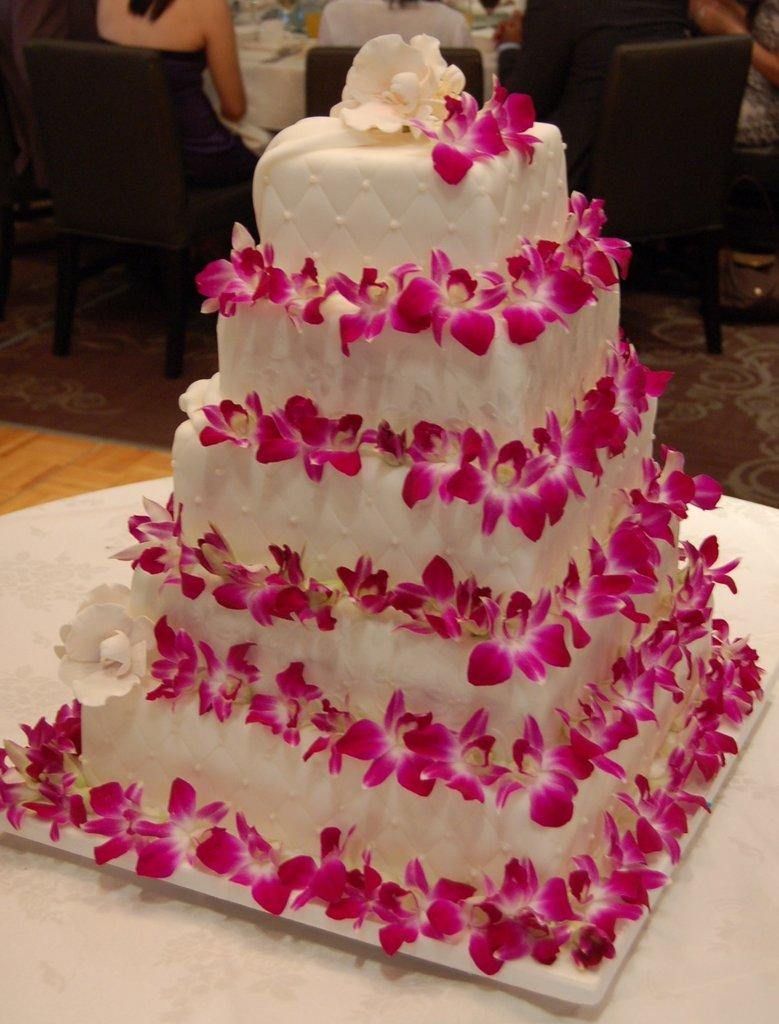What is the main subject of the image? There is a cake in the image. How is the cake decorated? The cake is decorated with flowers. Where is the cake located? The cake is on a table. What can be seen in the background of the image? There are chairs in the background of the image. Are there any people present in the image? Yes, some people are sitting in the chairs. What type of rail can be seen connecting the cake to the chairs in the image? There is no rail connecting the cake to the chairs in the image. Is there a prison visible in the background of the image? There is no prison present in the image; it features a cake, flowers, a table, chairs, and people sitting in the chairs. 